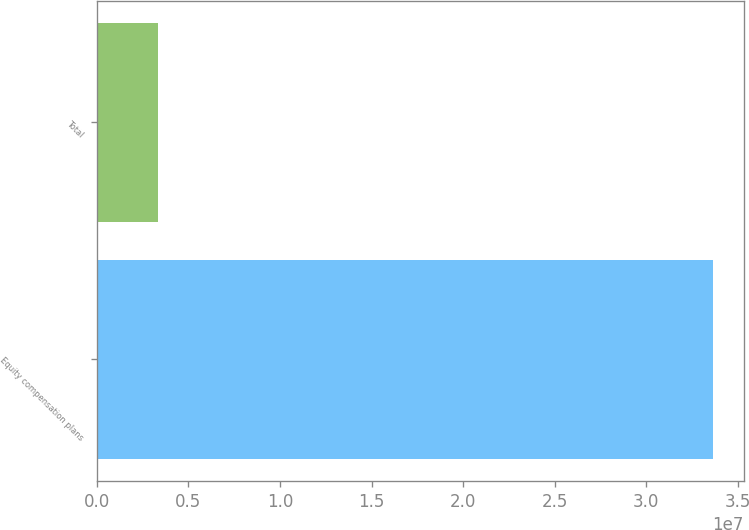<chart> <loc_0><loc_0><loc_500><loc_500><bar_chart><fcel>Equity compensation plans<fcel>Total<nl><fcel>3.36391e+07<fcel>3.36391e+06<nl></chart> 